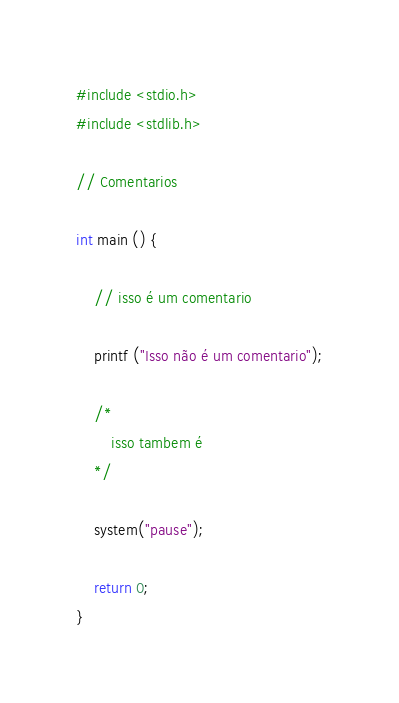Convert code to text. <code><loc_0><loc_0><loc_500><loc_500><_C_>#include <stdio.h>
#include <stdlib.h>

// Comentarios

int main () {

    // isso é um comentario

    printf ("Isso não é um comentario");

    /*
        isso tambem é
    */

    system("pause");

    return 0;
}</code> 